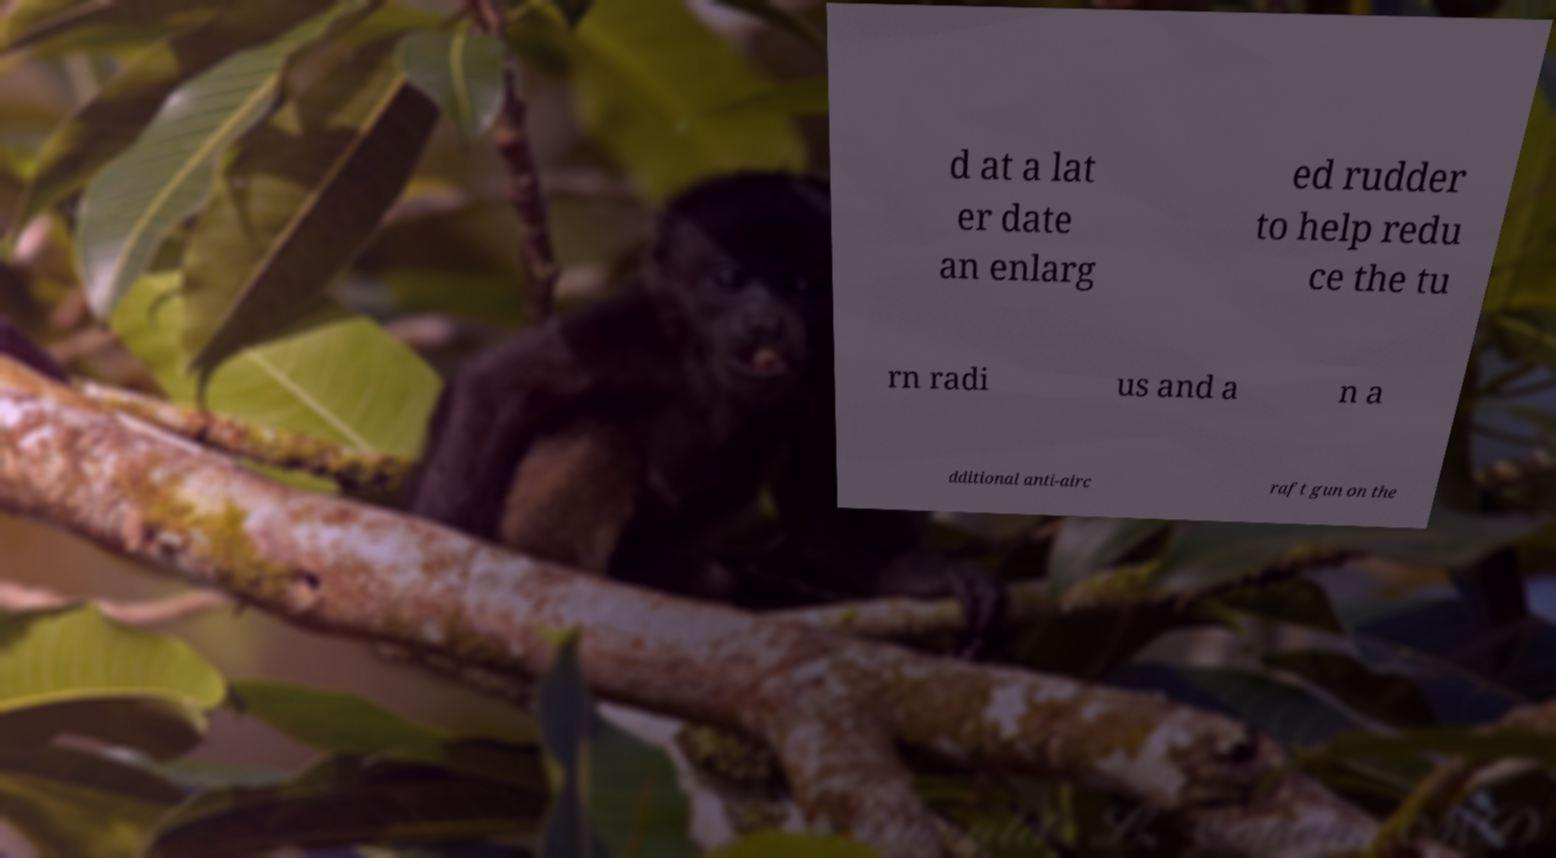Please identify and transcribe the text found in this image. d at a lat er date an enlarg ed rudder to help redu ce the tu rn radi us and a n a dditional anti-airc raft gun on the 